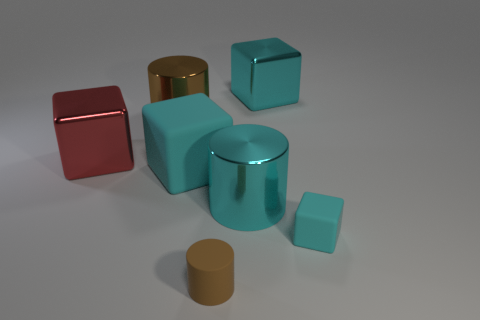Subtract all cyan blocks. How many were subtracted if there are1cyan blocks left? 2 Subtract all tiny brown cylinders. How many cylinders are left? 2 Add 2 large yellow matte cylinders. How many objects exist? 9 Subtract all green blocks. How many brown cylinders are left? 2 Subtract all cyan blocks. How many blocks are left? 1 Subtract 2 blocks. How many blocks are left? 2 Subtract all blocks. How many objects are left? 3 Subtract all blue blocks. Subtract all blue cylinders. How many blocks are left? 4 Subtract all large metallic cubes. Subtract all tiny brown rubber cylinders. How many objects are left? 4 Add 2 brown matte cylinders. How many brown matte cylinders are left? 3 